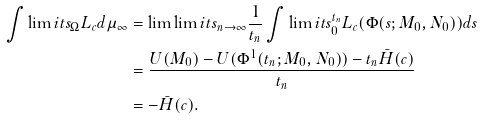Convert formula to latex. <formula><loc_0><loc_0><loc_500><loc_500>\int \lim i t s _ { \Omega } L _ { c } d \mu _ { \infty } & = \lim \lim i t s _ { n \to \infty } \frac { 1 } { t _ { n } } \int \lim i t s _ { 0 } ^ { t _ { n } } L _ { c } ( \Phi ( s ; M _ { 0 } , N _ { 0 } ) ) d s \\ & = \frac { U ( M _ { 0 } ) - U ( \Phi ^ { 1 } ( t _ { n } ; M _ { 0 } , N _ { 0 } ) ) - t _ { n } \bar { H } ( c ) } { t _ { n } } \\ & = - \bar { H } ( c ) .</formula> 